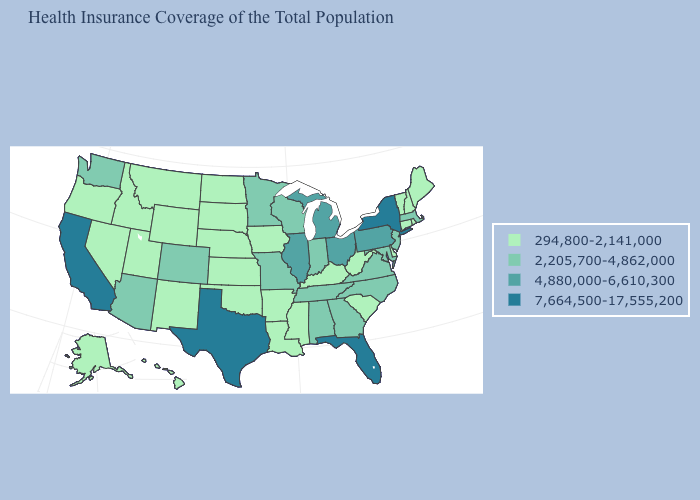Does the map have missing data?
Write a very short answer. No. What is the lowest value in the USA?
Give a very brief answer. 294,800-2,141,000. Which states have the lowest value in the West?
Short answer required. Alaska, Hawaii, Idaho, Montana, Nevada, New Mexico, Oregon, Utah, Wyoming. What is the value of California?
Quick response, please. 7,664,500-17,555,200. Does Arizona have the lowest value in the USA?
Quick response, please. No. What is the value of Texas?
Concise answer only. 7,664,500-17,555,200. Which states have the lowest value in the USA?
Quick response, please. Alaska, Arkansas, Connecticut, Delaware, Hawaii, Idaho, Iowa, Kansas, Kentucky, Louisiana, Maine, Mississippi, Montana, Nebraska, Nevada, New Hampshire, New Mexico, North Dakota, Oklahoma, Oregon, Rhode Island, South Carolina, South Dakota, Utah, Vermont, West Virginia, Wyoming. What is the value of New York?
Concise answer only. 7,664,500-17,555,200. Does the map have missing data?
Write a very short answer. No. What is the value of Pennsylvania?
Answer briefly. 4,880,000-6,610,300. Which states have the lowest value in the USA?
Concise answer only. Alaska, Arkansas, Connecticut, Delaware, Hawaii, Idaho, Iowa, Kansas, Kentucky, Louisiana, Maine, Mississippi, Montana, Nebraska, Nevada, New Hampshire, New Mexico, North Dakota, Oklahoma, Oregon, Rhode Island, South Carolina, South Dakota, Utah, Vermont, West Virginia, Wyoming. What is the value of Ohio?
Write a very short answer. 4,880,000-6,610,300. Does Indiana have the lowest value in the USA?
Keep it brief. No. Name the states that have a value in the range 4,880,000-6,610,300?
Quick response, please. Illinois, Michigan, Ohio, Pennsylvania. Does Alabama have the same value as North Carolina?
Answer briefly. Yes. 